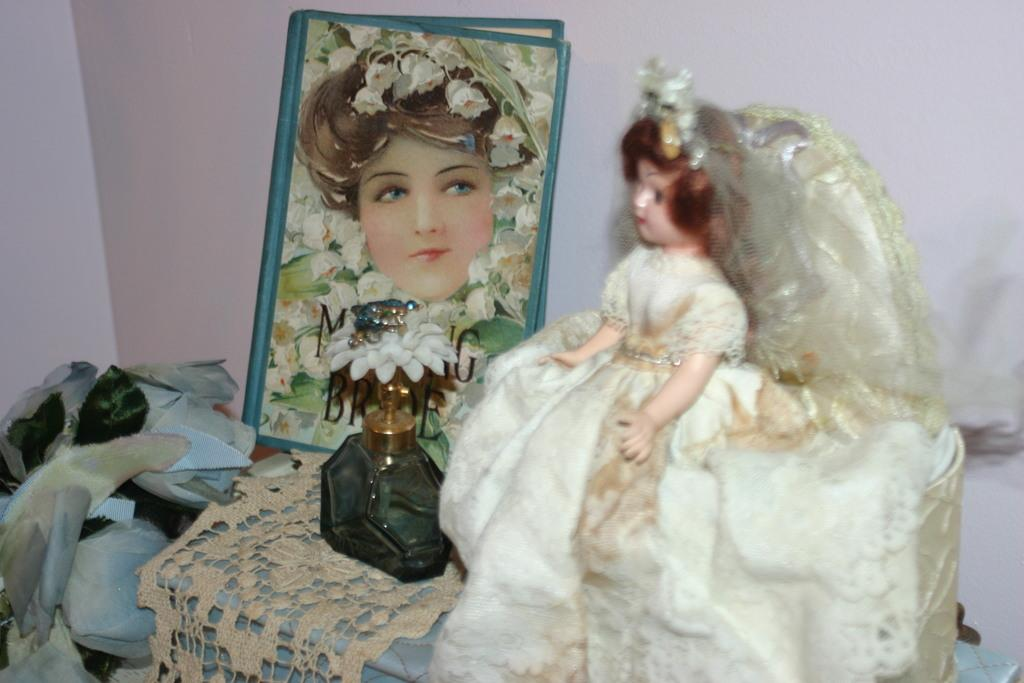What object is the main focus of the image? There is a doll in the image. What other items can be seen in the image? There is a photo frame and a perfume bottle in the image. What is visible in the background of the image? There is a wall in the background of the image. How many pies are being baked in the image? There are no pies present in the image. 